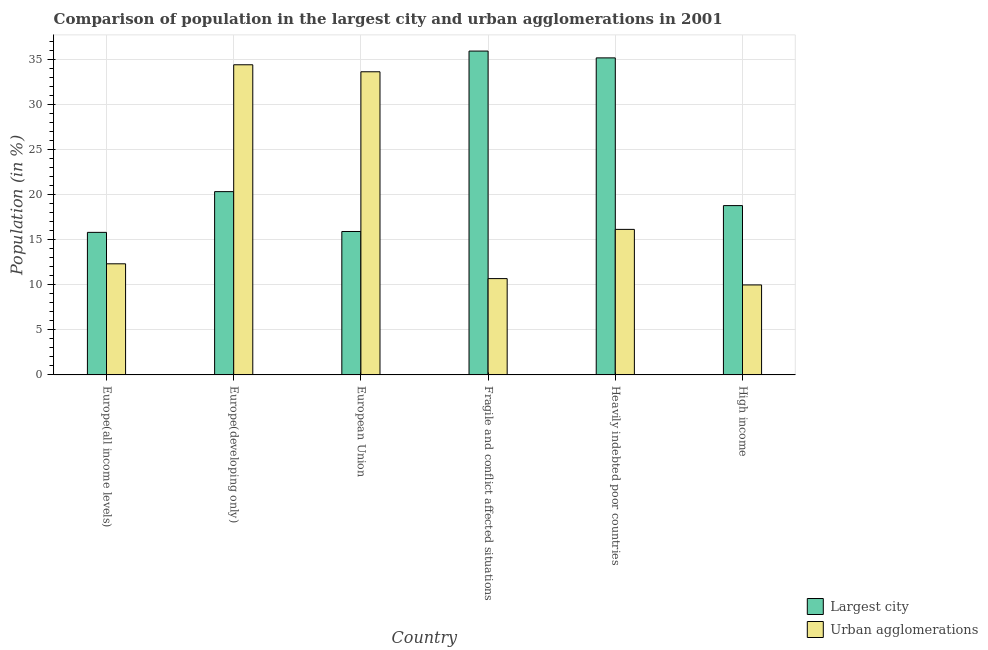Are the number of bars per tick equal to the number of legend labels?
Your response must be concise. Yes. How many bars are there on the 6th tick from the left?
Provide a short and direct response. 2. What is the label of the 2nd group of bars from the left?
Keep it short and to the point. Europe(developing only). In how many cases, is the number of bars for a given country not equal to the number of legend labels?
Offer a very short reply. 0. What is the population in urban agglomerations in Europe(all income levels)?
Ensure brevity in your answer.  12.32. Across all countries, what is the maximum population in the largest city?
Give a very brief answer. 35.9. Across all countries, what is the minimum population in the largest city?
Keep it short and to the point. 15.8. In which country was the population in the largest city maximum?
Your answer should be very brief. Fragile and conflict affected situations. In which country was the population in the largest city minimum?
Your response must be concise. Europe(all income levels). What is the total population in urban agglomerations in the graph?
Make the answer very short. 117.09. What is the difference between the population in the largest city in Europe(all income levels) and that in Fragile and conflict affected situations?
Your response must be concise. -20.1. What is the difference between the population in urban agglomerations in Heavily indebted poor countries and the population in the largest city in High income?
Your response must be concise. -2.64. What is the average population in the largest city per country?
Your response must be concise. 23.64. What is the difference between the population in urban agglomerations and population in the largest city in Fragile and conflict affected situations?
Offer a terse response. -25.22. In how many countries, is the population in the largest city greater than 7 %?
Your answer should be very brief. 6. What is the ratio of the population in the largest city in Europe(developing only) to that in Fragile and conflict affected situations?
Offer a terse response. 0.57. Is the population in urban agglomerations in Fragile and conflict affected situations less than that in Heavily indebted poor countries?
Your answer should be very brief. Yes. What is the difference between the highest and the second highest population in urban agglomerations?
Make the answer very short. 0.78. What is the difference between the highest and the lowest population in the largest city?
Your answer should be compact. 20.1. Is the sum of the population in the largest city in European Union and High income greater than the maximum population in urban agglomerations across all countries?
Your response must be concise. Yes. What does the 2nd bar from the left in European Union represents?
Make the answer very short. Urban agglomerations. What does the 2nd bar from the right in Europe(all income levels) represents?
Your answer should be very brief. Largest city. How many bars are there?
Make the answer very short. 12. How many countries are there in the graph?
Your answer should be compact. 6. Does the graph contain any zero values?
Offer a terse response. No. Does the graph contain grids?
Make the answer very short. Yes. Where does the legend appear in the graph?
Provide a succinct answer. Bottom right. How many legend labels are there?
Give a very brief answer. 2. What is the title of the graph?
Provide a short and direct response. Comparison of population in the largest city and urban agglomerations in 2001. What is the Population (in %) of Largest city in Europe(all income levels)?
Offer a very short reply. 15.8. What is the Population (in %) of Urban agglomerations in Europe(all income levels)?
Your response must be concise. 12.32. What is the Population (in %) in Largest city in Europe(developing only)?
Your answer should be compact. 20.32. What is the Population (in %) of Urban agglomerations in Europe(developing only)?
Give a very brief answer. 34.38. What is the Population (in %) in Largest city in European Union?
Offer a terse response. 15.9. What is the Population (in %) of Urban agglomerations in European Union?
Make the answer very short. 33.61. What is the Population (in %) of Largest city in Fragile and conflict affected situations?
Your response must be concise. 35.9. What is the Population (in %) of Urban agglomerations in Fragile and conflict affected situations?
Keep it short and to the point. 10.68. What is the Population (in %) in Largest city in Heavily indebted poor countries?
Your response must be concise. 35.15. What is the Population (in %) of Urban agglomerations in Heavily indebted poor countries?
Give a very brief answer. 16.13. What is the Population (in %) of Largest city in High income?
Keep it short and to the point. 18.77. What is the Population (in %) in Urban agglomerations in High income?
Provide a short and direct response. 9.97. Across all countries, what is the maximum Population (in %) in Largest city?
Your answer should be compact. 35.9. Across all countries, what is the maximum Population (in %) of Urban agglomerations?
Offer a terse response. 34.38. Across all countries, what is the minimum Population (in %) of Largest city?
Give a very brief answer. 15.8. Across all countries, what is the minimum Population (in %) of Urban agglomerations?
Your answer should be very brief. 9.97. What is the total Population (in %) of Largest city in the graph?
Your response must be concise. 141.84. What is the total Population (in %) in Urban agglomerations in the graph?
Provide a succinct answer. 117.09. What is the difference between the Population (in %) of Largest city in Europe(all income levels) and that in Europe(developing only)?
Your answer should be very brief. -4.51. What is the difference between the Population (in %) in Urban agglomerations in Europe(all income levels) and that in Europe(developing only)?
Provide a succinct answer. -22.06. What is the difference between the Population (in %) of Largest city in Europe(all income levels) and that in European Union?
Keep it short and to the point. -0.1. What is the difference between the Population (in %) of Urban agglomerations in Europe(all income levels) and that in European Union?
Provide a short and direct response. -21.29. What is the difference between the Population (in %) of Largest city in Europe(all income levels) and that in Fragile and conflict affected situations?
Offer a terse response. -20.1. What is the difference between the Population (in %) in Urban agglomerations in Europe(all income levels) and that in Fragile and conflict affected situations?
Provide a succinct answer. 1.64. What is the difference between the Population (in %) of Largest city in Europe(all income levels) and that in Heavily indebted poor countries?
Make the answer very short. -19.34. What is the difference between the Population (in %) of Urban agglomerations in Europe(all income levels) and that in Heavily indebted poor countries?
Provide a succinct answer. -3.82. What is the difference between the Population (in %) in Largest city in Europe(all income levels) and that in High income?
Your response must be concise. -2.97. What is the difference between the Population (in %) in Urban agglomerations in Europe(all income levels) and that in High income?
Your answer should be very brief. 2.34. What is the difference between the Population (in %) of Largest city in Europe(developing only) and that in European Union?
Your answer should be compact. 4.42. What is the difference between the Population (in %) of Urban agglomerations in Europe(developing only) and that in European Union?
Your response must be concise. 0.78. What is the difference between the Population (in %) in Largest city in Europe(developing only) and that in Fragile and conflict affected situations?
Your answer should be compact. -15.58. What is the difference between the Population (in %) in Urban agglomerations in Europe(developing only) and that in Fragile and conflict affected situations?
Provide a succinct answer. 23.71. What is the difference between the Population (in %) of Largest city in Europe(developing only) and that in Heavily indebted poor countries?
Give a very brief answer. -14.83. What is the difference between the Population (in %) in Urban agglomerations in Europe(developing only) and that in Heavily indebted poor countries?
Provide a succinct answer. 18.25. What is the difference between the Population (in %) of Largest city in Europe(developing only) and that in High income?
Provide a succinct answer. 1.55. What is the difference between the Population (in %) of Urban agglomerations in Europe(developing only) and that in High income?
Your answer should be very brief. 24.41. What is the difference between the Population (in %) of Largest city in European Union and that in Fragile and conflict affected situations?
Keep it short and to the point. -20. What is the difference between the Population (in %) of Urban agglomerations in European Union and that in Fragile and conflict affected situations?
Provide a short and direct response. 22.93. What is the difference between the Population (in %) of Largest city in European Union and that in Heavily indebted poor countries?
Offer a terse response. -19.25. What is the difference between the Population (in %) of Urban agglomerations in European Union and that in Heavily indebted poor countries?
Give a very brief answer. 17.47. What is the difference between the Population (in %) of Largest city in European Union and that in High income?
Your response must be concise. -2.87. What is the difference between the Population (in %) of Urban agglomerations in European Union and that in High income?
Your response must be concise. 23.63. What is the difference between the Population (in %) in Largest city in Fragile and conflict affected situations and that in Heavily indebted poor countries?
Offer a terse response. 0.75. What is the difference between the Population (in %) in Urban agglomerations in Fragile and conflict affected situations and that in Heavily indebted poor countries?
Your answer should be very brief. -5.46. What is the difference between the Population (in %) in Largest city in Fragile and conflict affected situations and that in High income?
Your response must be concise. 17.13. What is the difference between the Population (in %) in Urban agglomerations in Fragile and conflict affected situations and that in High income?
Make the answer very short. 0.7. What is the difference between the Population (in %) in Largest city in Heavily indebted poor countries and that in High income?
Give a very brief answer. 16.38. What is the difference between the Population (in %) of Urban agglomerations in Heavily indebted poor countries and that in High income?
Make the answer very short. 6.16. What is the difference between the Population (in %) in Largest city in Europe(all income levels) and the Population (in %) in Urban agglomerations in Europe(developing only)?
Make the answer very short. -18.58. What is the difference between the Population (in %) of Largest city in Europe(all income levels) and the Population (in %) of Urban agglomerations in European Union?
Make the answer very short. -17.8. What is the difference between the Population (in %) of Largest city in Europe(all income levels) and the Population (in %) of Urban agglomerations in Fragile and conflict affected situations?
Make the answer very short. 5.13. What is the difference between the Population (in %) of Largest city in Europe(all income levels) and the Population (in %) of Urban agglomerations in Heavily indebted poor countries?
Provide a short and direct response. -0.33. What is the difference between the Population (in %) in Largest city in Europe(all income levels) and the Population (in %) in Urban agglomerations in High income?
Your answer should be compact. 5.83. What is the difference between the Population (in %) of Largest city in Europe(developing only) and the Population (in %) of Urban agglomerations in European Union?
Your answer should be compact. -13.29. What is the difference between the Population (in %) of Largest city in Europe(developing only) and the Population (in %) of Urban agglomerations in Fragile and conflict affected situations?
Keep it short and to the point. 9.64. What is the difference between the Population (in %) in Largest city in Europe(developing only) and the Population (in %) in Urban agglomerations in Heavily indebted poor countries?
Keep it short and to the point. 4.18. What is the difference between the Population (in %) of Largest city in Europe(developing only) and the Population (in %) of Urban agglomerations in High income?
Your answer should be very brief. 10.34. What is the difference between the Population (in %) in Largest city in European Union and the Population (in %) in Urban agglomerations in Fragile and conflict affected situations?
Make the answer very short. 5.22. What is the difference between the Population (in %) in Largest city in European Union and the Population (in %) in Urban agglomerations in Heavily indebted poor countries?
Ensure brevity in your answer.  -0.23. What is the difference between the Population (in %) in Largest city in European Union and the Population (in %) in Urban agglomerations in High income?
Give a very brief answer. 5.92. What is the difference between the Population (in %) of Largest city in Fragile and conflict affected situations and the Population (in %) of Urban agglomerations in Heavily indebted poor countries?
Your answer should be compact. 19.77. What is the difference between the Population (in %) of Largest city in Fragile and conflict affected situations and the Population (in %) of Urban agglomerations in High income?
Make the answer very short. 25.93. What is the difference between the Population (in %) of Largest city in Heavily indebted poor countries and the Population (in %) of Urban agglomerations in High income?
Give a very brief answer. 25.17. What is the average Population (in %) in Largest city per country?
Provide a succinct answer. 23.64. What is the average Population (in %) of Urban agglomerations per country?
Your answer should be compact. 19.51. What is the difference between the Population (in %) in Largest city and Population (in %) in Urban agglomerations in Europe(all income levels)?
Your answer should be very brief. 3.49. What is the difference between the Population (in %) in Largest city and Population (in %) in Urban agglomerations in Europe(developing only)?
Your answer should be compact. -14.06. What is the difference between the Population (in %) in Largest city and Population (in %) in Urban agglomerations in European Union?
Your response must be concise. -17.71. What is the difference between the Population (in %) of Largest city and Population (in %) of Urban agglomerations in Fragile and conflict affected situations?
Offer a very short reply. 25.22. What is the difference between the Population (in %) in Largest city and Population (in %) in Urban agglomerations in Heavily indebted poor countries?
Your answer should be compact. 19.01. What is the difference between the Population (in %) in Largest city and Population (in %) in Urban agglomerations in High income?
Ensure brevity in your answer.  8.8. What is the ratio of the Population (in %) in Largest city in Europe(all income levels) to that in Europe(developing only)?
Provide a succinct answer. 0.78. What is the ratio of the Population (in %) in Urban agglomerations in Europe(all income levels) to that in Europe(developing only)?
Make the answer very short. 0.36. What is the ratio of the Population (in %) in Largest city in Europe(all income levels) to that in European Union?
Make the answer very short. 0.99. What is the ratio of the Population (in %) of Urban agglomerations in Europe(all income levels) to that in European Union?
Provide a succinct answer. 0.37. What is the ratio of the Population (in %) of Largest city in Europe(all income levels) to that in Fragile and conflict affected situations?
Provide a short and direct response. 0.44. What is the ratio of the Population (in %) in Urban agglomerations in Europe(all income levels) to that in Fragile and conflict affected situations?
Make the answer very short. 1.15. What is the ratio of the Population (in %) of Largest city in Europe(all income levels) to that in Heavily indebted poor countries?
Provide a short and direct response. 0.45. What is the ratio of the Population (in %) of Urban agglomerations in Europe(all income levels) to that in Heavily indebted poor countries?
Your response must be concise. 0.76. What is the ratio of the Population (in %) of Largest city in Europe(all income levels) to that in High income?
Your answer should be compact. 0.84. What is the ratio of the Population (in %) of Urban agglomerations in Europe(all income levels) to that in High income?
Give a very brief answer. 1.23. What is the ratio of the Population (in %) of Largest city in Europe(developing only) to that in European Union?
Your answer should be very brief. 1.28. What is the ratio of the Population (in %) in Urban agglomerations in Europe(developing only) to that in European Union?
Keep it short and to the point. 1.02. What is the ratio of the Population (in %) of Largest city in Europe(developing only) to that in Fragile and conflict affected situations?
Ensure brevity in your answer.  0.57. What is the ratio of the Population (in %) in Urban agglomerations in Europe(developing only) to that in Fragile and conflict affected situations?
Provide a short and direct response. 3.22. What is the ratio of the Population (in %) in Largest city in Europe(developing only) to that in Heavily indebted poor countries?
Offer a terse response. 0.58. What is the ratio of the Population (in %) in Urban agglomerations in Europe(developing only) to that in Heavily indebted poor countries?
Ensure brevity in your answer.  2.13. What is the ratio of the Population (in %) in Largest city in Europe(developing only) to that in High income?
Make the answer very short. 1.08. What is the ratio of the Population (in %) of Urban agglomerations in Europe(developing only) to that in High income?
Keep it short and to the point. 3.45. What is the ratio of the Population (in %) in Largest city in European Union to that in Fragile and conflict affected situations?
Your answer should be very brief. 0.44. What is the ratio of the Population (in %) of Urban agglomerations in European Union to that in Fragile and conflict affected situations?
Your response must be concise. 3.15. What is the ratio of the Population (in %) of Largest city in European Union to that in Heavily indebted poor countries?
Your response must be concise. 0.45. What is the ratio of the Population (in %) in Urban agglomerations in European Union to that in Heavily indebted poor countries?
Make the answer very short. 2.08. What is the ratio of the Population (in %) of Largest city in European Union to that in High income?
Give a very brief answer. 0.85. What is the ratio of the Population (in %) in Urban agglomerations in European Union to that in High income?
Your answer should be very brief. 3.37. What is the ratio of the Population (in %) in Largest city in Fragile and conflict affected situations to that in Heavily indebted poor countries?
Give a very brief answer. 1.02. What is the ratio of the Population (in %) of Urban agglomerations in Fragile and conflict affected situations to that in Heavily indebted poor countries?
Make the answer very short. 0.66. What is the ratio of the Population (in %) of Largest city in Fragile and conflict affected situations to that in High income?
Your answer should be very brief. 1.91. What is the ratio of the Population (in %) of Urban agglomerations in Fragile and conflict affected situations to that in High income?
Offer a very short reply. 1.07. What is the ratio of the Population (in %) in Largest city in Heavily indebted poor countries to that in High income?
Keep it short and to the point. 1.87. What is the ratio of the Population (in %) of Urban agglomerations in Heavily indebted poor countries to that in High income?
Keep it short and to the point. 1.62. What is the difference between the highest and the second highest Population (in %) in Largest city?
Offer a very short reply. 0.75. What is the difference between the highest and the second highest Population (in %) of Urban agglomerations?
Provide a succinct answer. 0.78. What is the difference between the highest and the lowest Population (in %) of Largest city?
Make the answer very short. 20.1. What is the difference between the highest and the lowest Population (in %) of Urban agglomerations?
Keep it short and to the point. 24.41. 